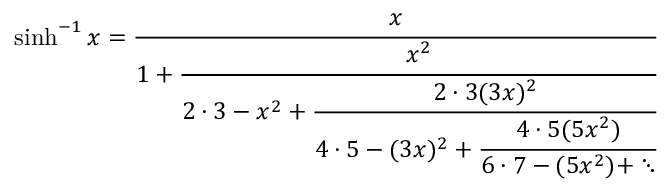Convert formula to latex. <formula><loc_0><loc_0><loc_500><loc_500>\sinh ^ { - 1 } x = { \cfrac { x } { 1 + { \cfrac { x ^ { 2 } } { 2 \cdot 3 - x ^ { 2 } + { \cfrac { 2 \cdot 3 ( 3 x ) ^ { 2 } } { 4 \cdot 5 - ( 3 x ) ^ { 2 } + { \cfrac { 4 \cdot 5 ( 5 x ^ { 2 } ) } { 6 \cdot 7 - ( 5 x ^ { 2 } ) + \ddots } } } } } } } }</formula> 